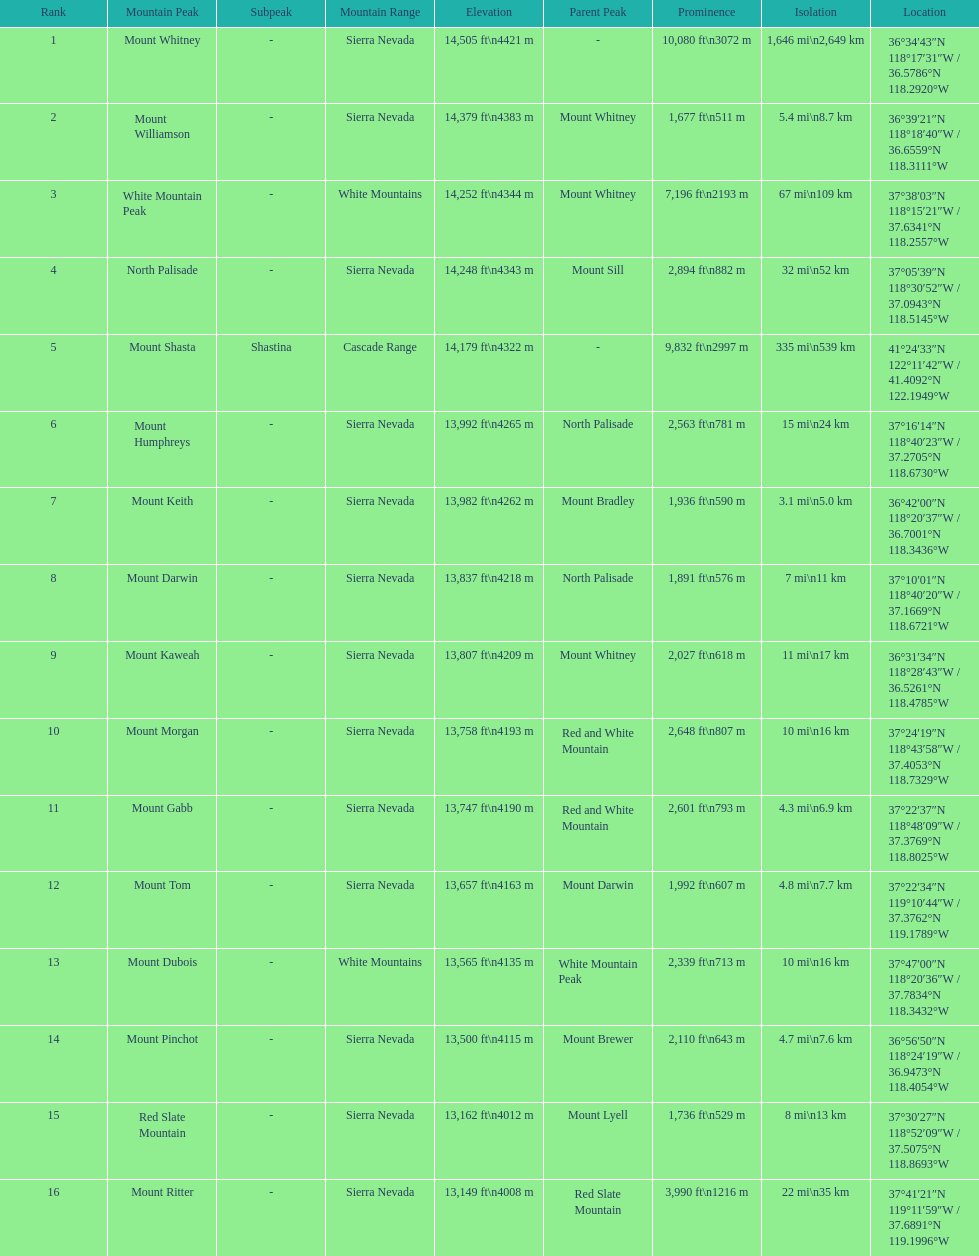Which mountain peak has the least isolation? Mount Keith. 